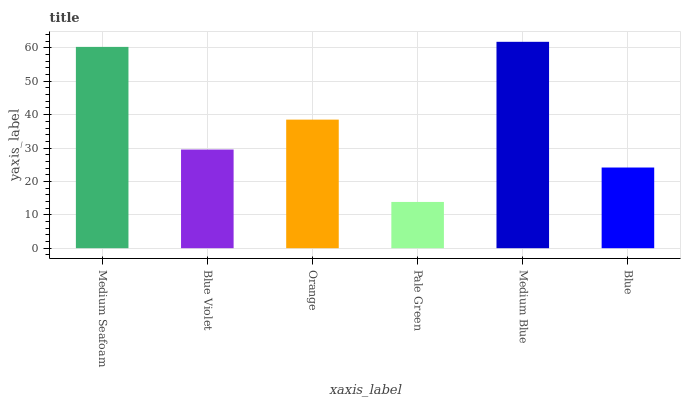Is Pale Green the minimum?
Answer yes or no. Yes. Is Medium Blue the maximum?
Answer yes or no. Yes. Is Blue Violet the minimum?
Answer yes or no. No. Is Blue Violet the maximum?
Answer yes or no. No. Is Medium Seafoam greater than Blue Violet?
Answer yes or no. Yes. Is Blue Violet less than Medium Seafoam?
Answer yes or no. Yes. Is Blue Violet greater than Medium Seafoam?
Answer yes or no. No. Is Medium Seafoam less than Blue Violet?
Answer yes or no. No. Is Orange the high median?
Answer yes or no. Yes. Is Blue Violet the low median?
Answer yes or no. Yes. Is Pale Green the high median?
Answer yes or no. No. Is Orange the low median?
Answer yes or no. No. 